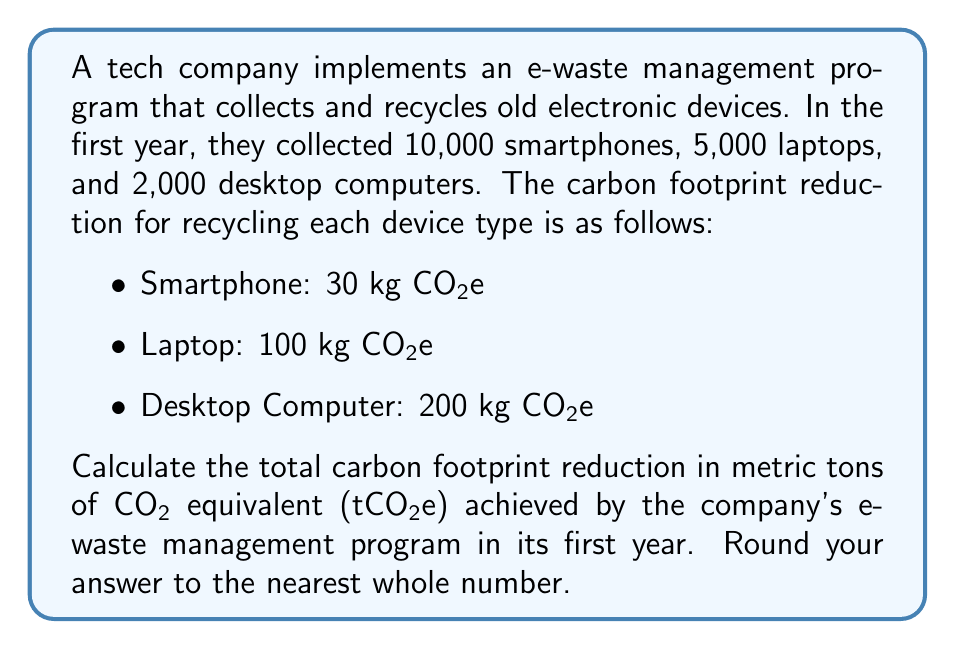Could you help me with this problem? To calculate the total carbon footprint reduction, we need to multiply the number of devices collected by their respective carbon footprint reduction values and sum the results. Then, we'll convert the total from kilograms to metric tons.

1. Calculate the reduction for smartphones:
   $10,000 \times 30 \text{ kg CO2e} = 300,000 \text{ kg CO2e}$

2. Calculate the reduction for laptops:
   $5,000 \times 100 \text{ kg CO2e} = 500,000 \text{ kg CO2e}$

3. Calculate the reduction for desktop computers:
   $2,000 \times 200 \text{ kg CO2e} = 400,000 \text{ kg CO2e}$

4. Sum the total reduction in kg CO2e:
   $300,000 + 500,000 + 400,000 = 1,200,000 \text{ kg CO2e}$

5. Convert kg to metric tons (1 metric ton = 1,000 kg):
   $$\frac{1,200,000 \text{ kg CO2e}}{1,000 \text{ kg/t}} = 1,200 \text{ tCO2e}$$

The final answer is 1,200 tCO2e, which is already a whole number and doesn't need rounding.
Answer: 1,200 tCO2e 